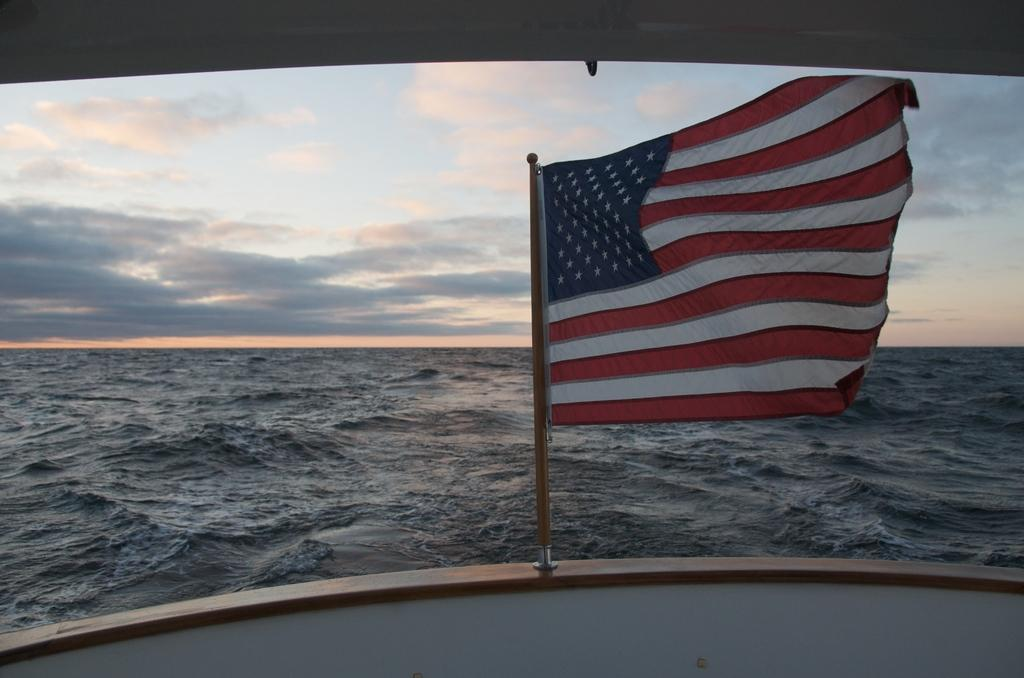What structure can be seen in the picture? There is a flag pole in the picture. What is attached to the flag pole? A flag is attached to the flag pole. What natural element is visible in the image? There is water visible in the image. What characteristic of the water can be observed? Waves are present in the water. How many clovers can be seen growing near the flag pole in the image? There are no clovers visible in the image; it features a flag pole with a flag and water with waves. 